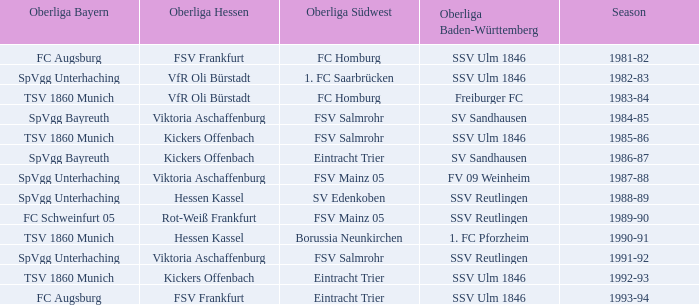Which team from the oberliga südwest had a link to sv sandhausen in the oberliga baden-württemberg during the 1984-85 season? FSV Salmrohr. 